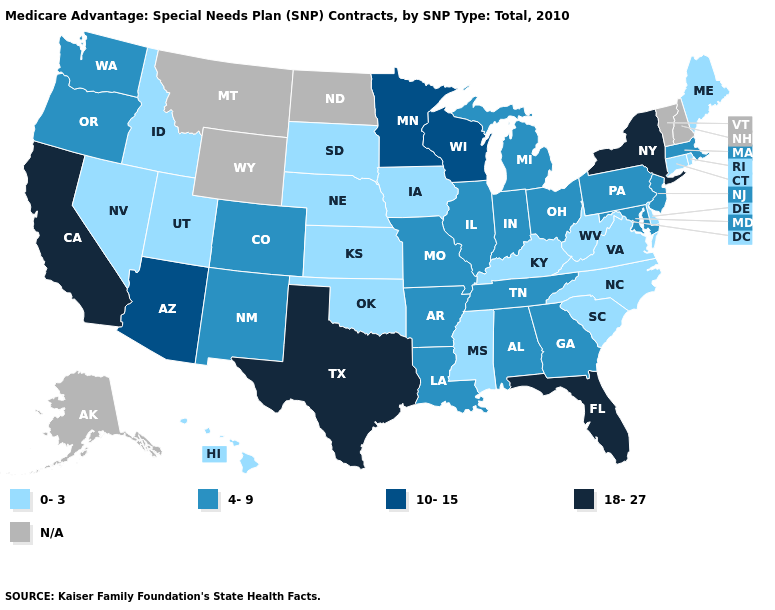Is the legend a continuous bar?
Keep it brief. No. Does the map have missing data?
Be succinct. Yes. Name the states that have a value in the range N/A?
Short answer required. Alaska, Montana, North Dakota, New Hampshire, Vermont, Wyoming. Name the states that have a value in the range N/A?
Give a very brief answer. Alaska, Montana, North Dakota, New Hampshire, Vermont, Wyoming. Name the states that have a value in the range N/A?
Give a very brief answer. Alaska, Montana, North Dakota, New Hampshire, Vermont, Wyoming. Which states hav the highest value in the Northeast?
Keep it brief. New York. What is the value of Michigan?
Answer briefly. 4-9. Does Ohio have the highest value in the MidWest?
Short answer required. No. Which states have the lowest value in the USA?
Short answer required. Connecticut, Delaware, Hawaii, Iowa, Idaho, Kansas, Kentucky, Maine, Mississippi, North Carolina, Nebraska, Nevada, Oklahoma, Rhode Island, South Carolina, South Dakota, Utah, Virginia, West Virginia. Among the states that border Ohio , does Kentucky have the lowest value?
Short answer required. Yes. Among the states that border Connecticut , does Massachusetts have the highest value?
Quick response, please. No. What is the value of Louisiana?
Quick response, please. 4-9. 